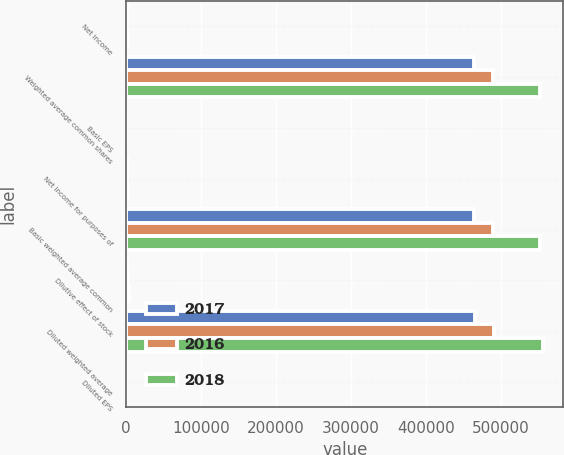Convert chart to OTSL. <chart><loc_0><loc_0><loc_500><loc_500><stacked_bar_chart><ecel><fcel>Net income<fcel>Weighted average common shares<fcel>Basic EPS<fcel>Net income for purposes of<fcel>Basic weighted average common<fcel>Dilutive effect of stock<fcel>Diluted weighted average<fcel>Diluted EPS<nl><fcel>2017<fcel>1412<fcel>464236<fcel>3.04<fcel>1412<fcel>464236<fcel>1424<fcel>465660<fcel>3.03<nl><fcel>2016<fcel>1282<fcel>489164<fcel>2.62<fcel>1282<fcel>489164<fcel>2528<fcel>491692<fcel>2.61<nl><fcel>2018<fcel>2584<fcel>552308<fcel>4.68<fcel>2584<fcel>552308<fcel>3791<fcel>556099<fcel>4.65<nl></chart> 